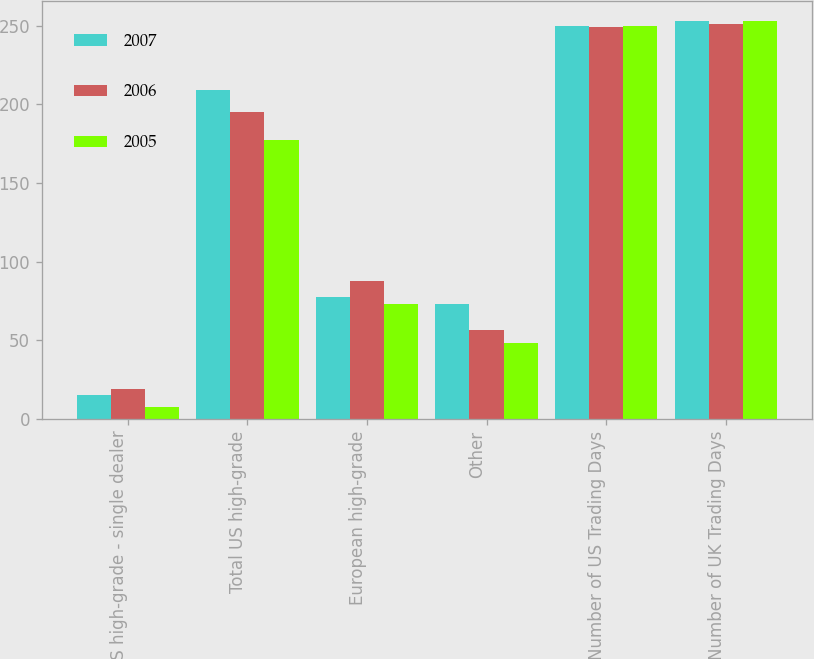<chart> <loc_0><loc_0><loc_500><loc_500><stacked_bar_chart><ecel><fcel>US high-grade - single dealer<fcel>Total US high-grade<fcel>European high-grade<fcel>Other<fcel>Number of US Trading Days<fcel>Number of UK Trading Days<nl><fcel>2007<fcel>15.1<fcel>209.2<fcel>77.4<fcel>73.3<fcel>250<fcel>253<nl><fcel>2006<fcel>19<fcel>195.4<fcel>87.6<fcel>56.6<fcel>249<fcel>251<nl><fcel>2005<fcel>7.5<fcel>177.6<fcel>73.4<fcel>48.2<fcel>250<fcel>253<nl></chart> 